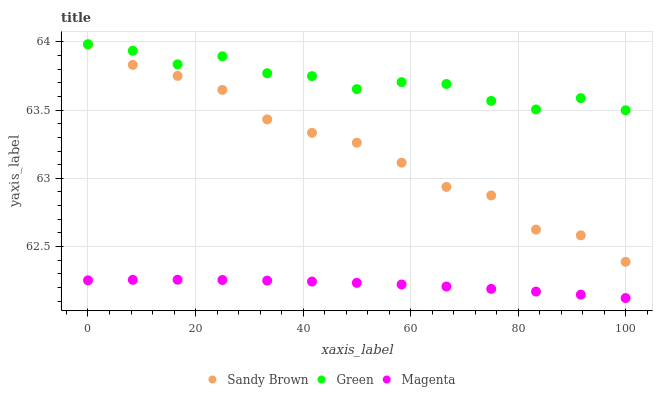Does Magenta have the minimum area under the curve?
Answer yes or no. Yes. Does Green have the maximum area under the curve?
Answer yes or no. Yes. Does Sandy Brown have the minimum area under the curve?
Answer yes or no. No. Does Sandy Brown have the maximum area under the curve?
Answer yes or no. No. Is Magenta the smoothest?
Answer yes or no. Yes. Is Green the roughest?
Answer yes or no. Yes. Is Sandy Brown the smoothest?
Answer yes or no. No. Is Sandy Brown the roughest?
Answer yes or no. No. Does Magenta have the lowest value?
Answer yes or no. Yes. Does Sandy Brown have the lowest value?
Answer yes or no. No. Does Green have the highest value?
Answer yes or no. Yes. Does Sandy Brown have the highest value?
Answer yes or no. No. Is Sandy Brown less than Green?
Answer yes or no. Yes. Is Sandy Brown greater than Magenta?
Answer yes or no. Yes. Does Sandy Brown intersect Green?
Answer yes or no. No. 